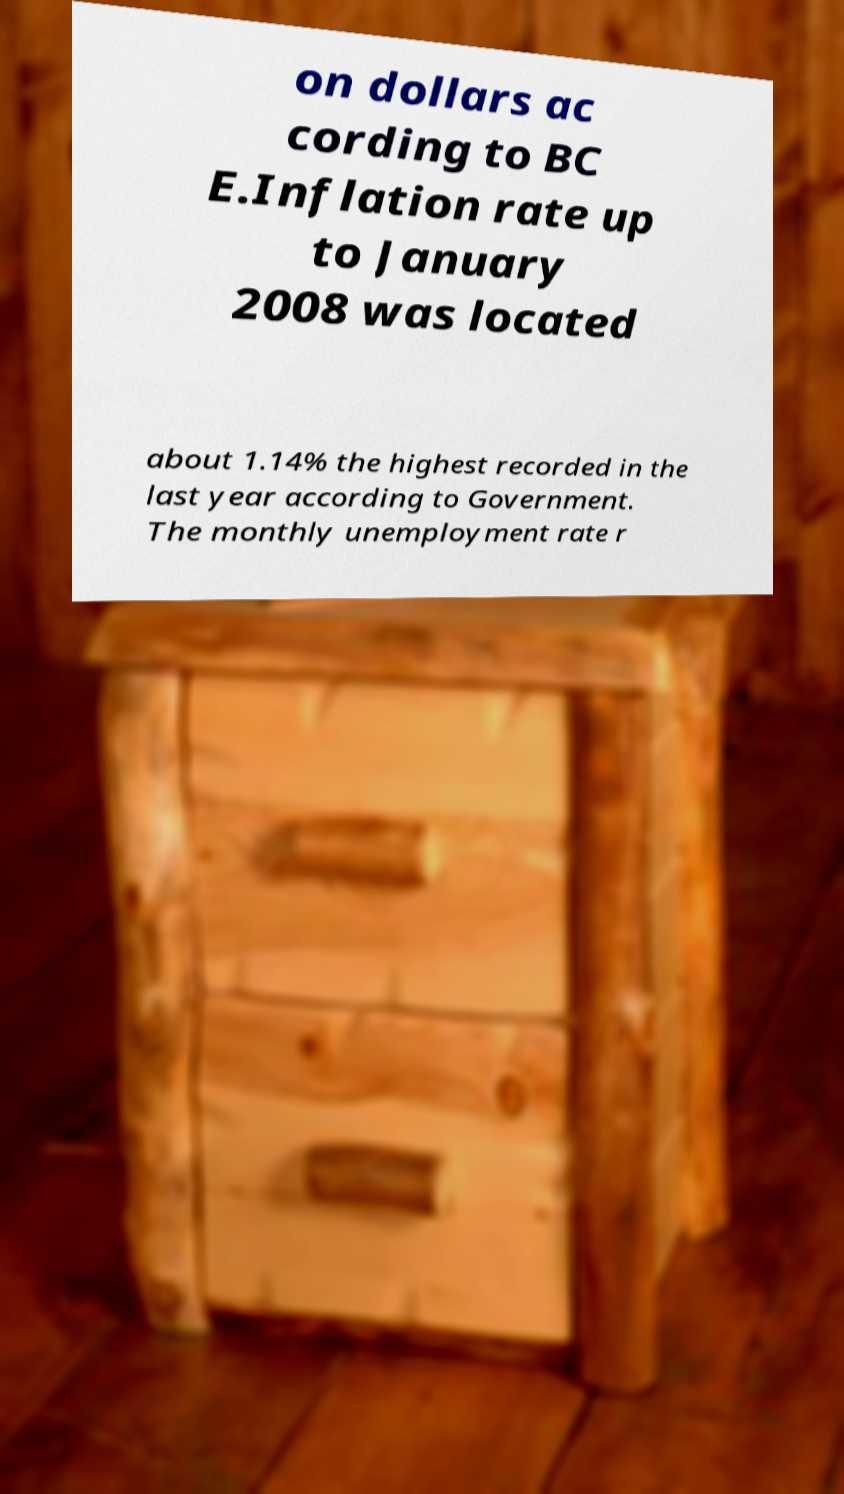I need the written content from this picture converted into text. Can you do that? on dollars ac cording to BC E.Inflation rate up to January 2008 was located about 1.14% the highest recorded in the last year according to Government. The monthly unemployment rate r 